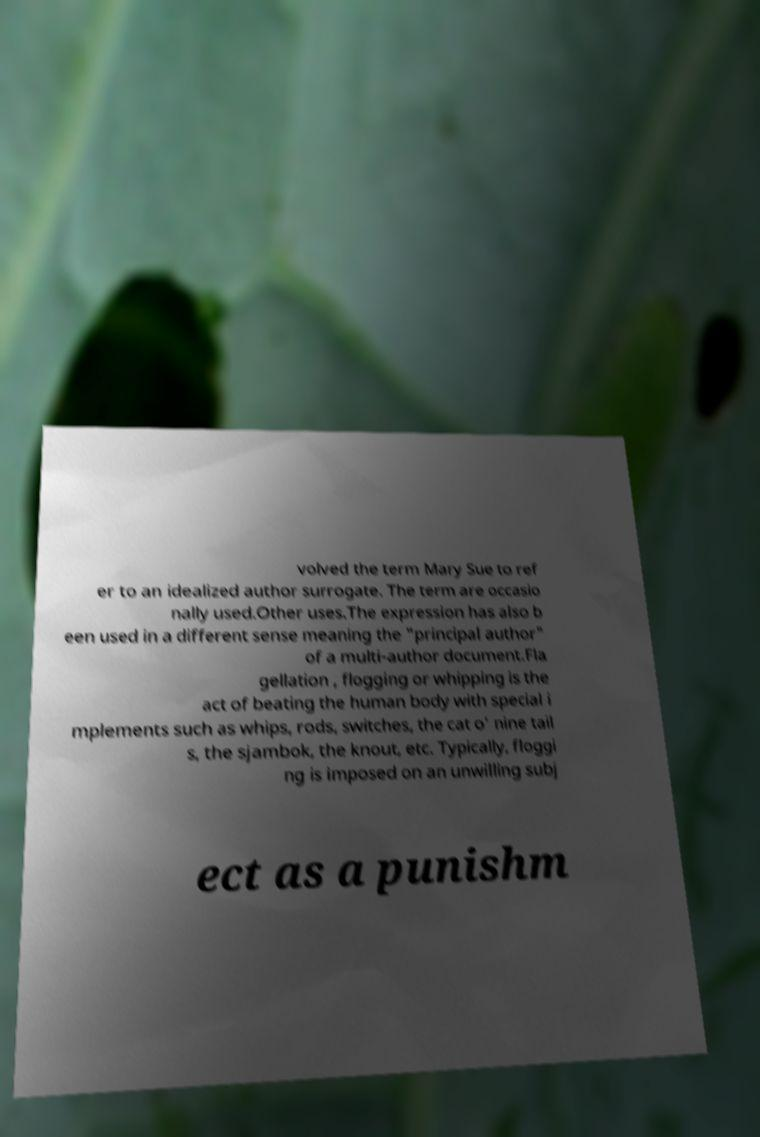Can you accurately transcribe the text from the provided image for me? volved the term Mary Sue to ref er to an idealized author surrogate. The term are occasio nally used.Other uses.The expression has also b een used in a different sense meaning the "principal author" of a multi-author document.Fla gellation , flogging or whipping is the act of beating the human body with special i mplements such as whips, rods, switches, the cat o' nine tail s, the sjambok, the knout, etc. Typically, floggi ng is imposed on an unwilling subj ect as a punishm 